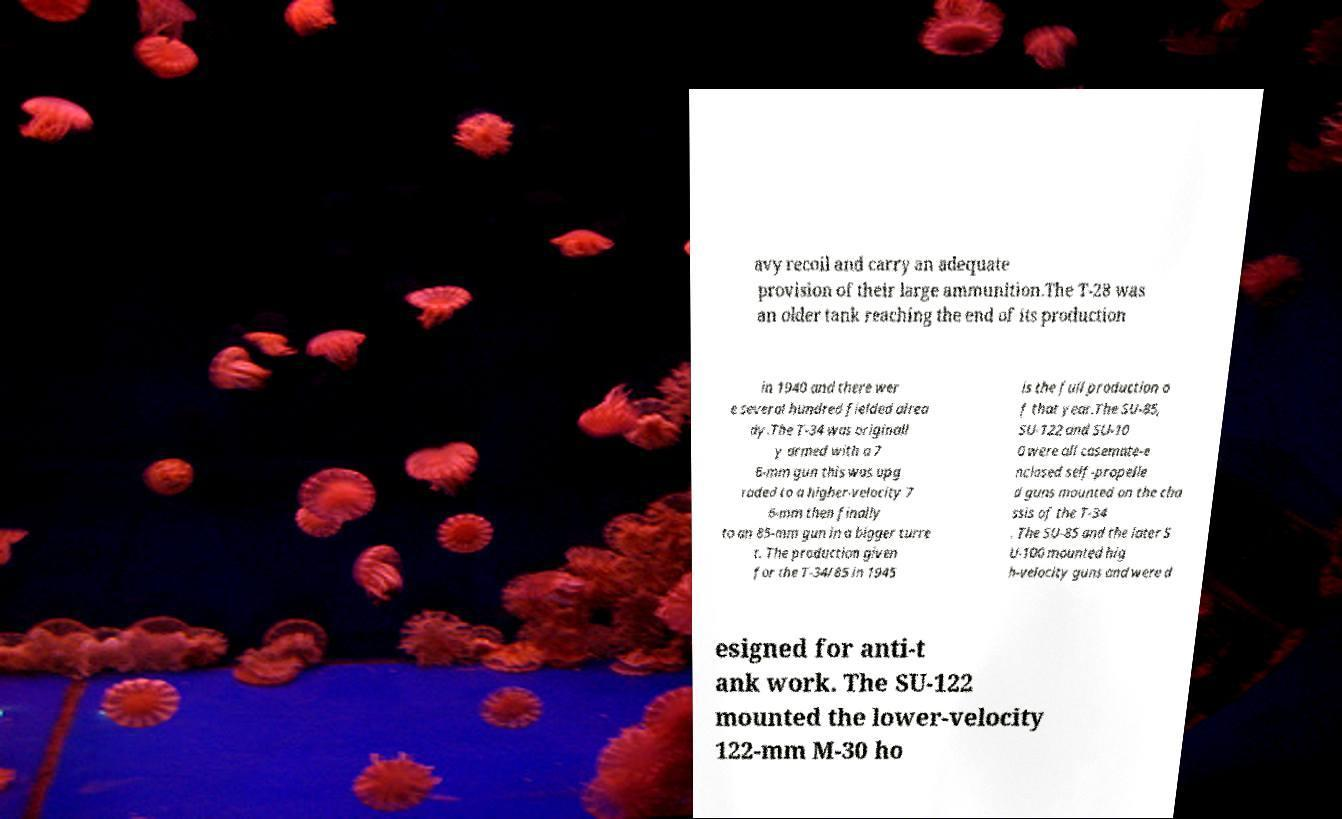What messages or text are displayed in this image? I need them in a readable, typed format. avy recoil and carry an adequate provision of their large ammunition.The T-28 was an older tank reaching the end of its production in 1940 and there wer e several hundred fielded alrea dy.The T-34 was originall y armed with a 7 6-mm gun this was upg raded to a higher-velocity 7 6-mm then finally to an 85-mm gun in a bigger turre t. The production given for the T-34/85 in 1945 is the full production o f that year.The SU-85, SU-122 and SU-10 0 were all casemate-e nclosed self-propelle d guns mounted on the cha ssis of the T-34 . The SU-85 and the later S U-100 mounted hig h-velocity guns and were d esigned for anti-t ank work. The SU-122 mounted the lower-velocity 122-mm M-30 ho 